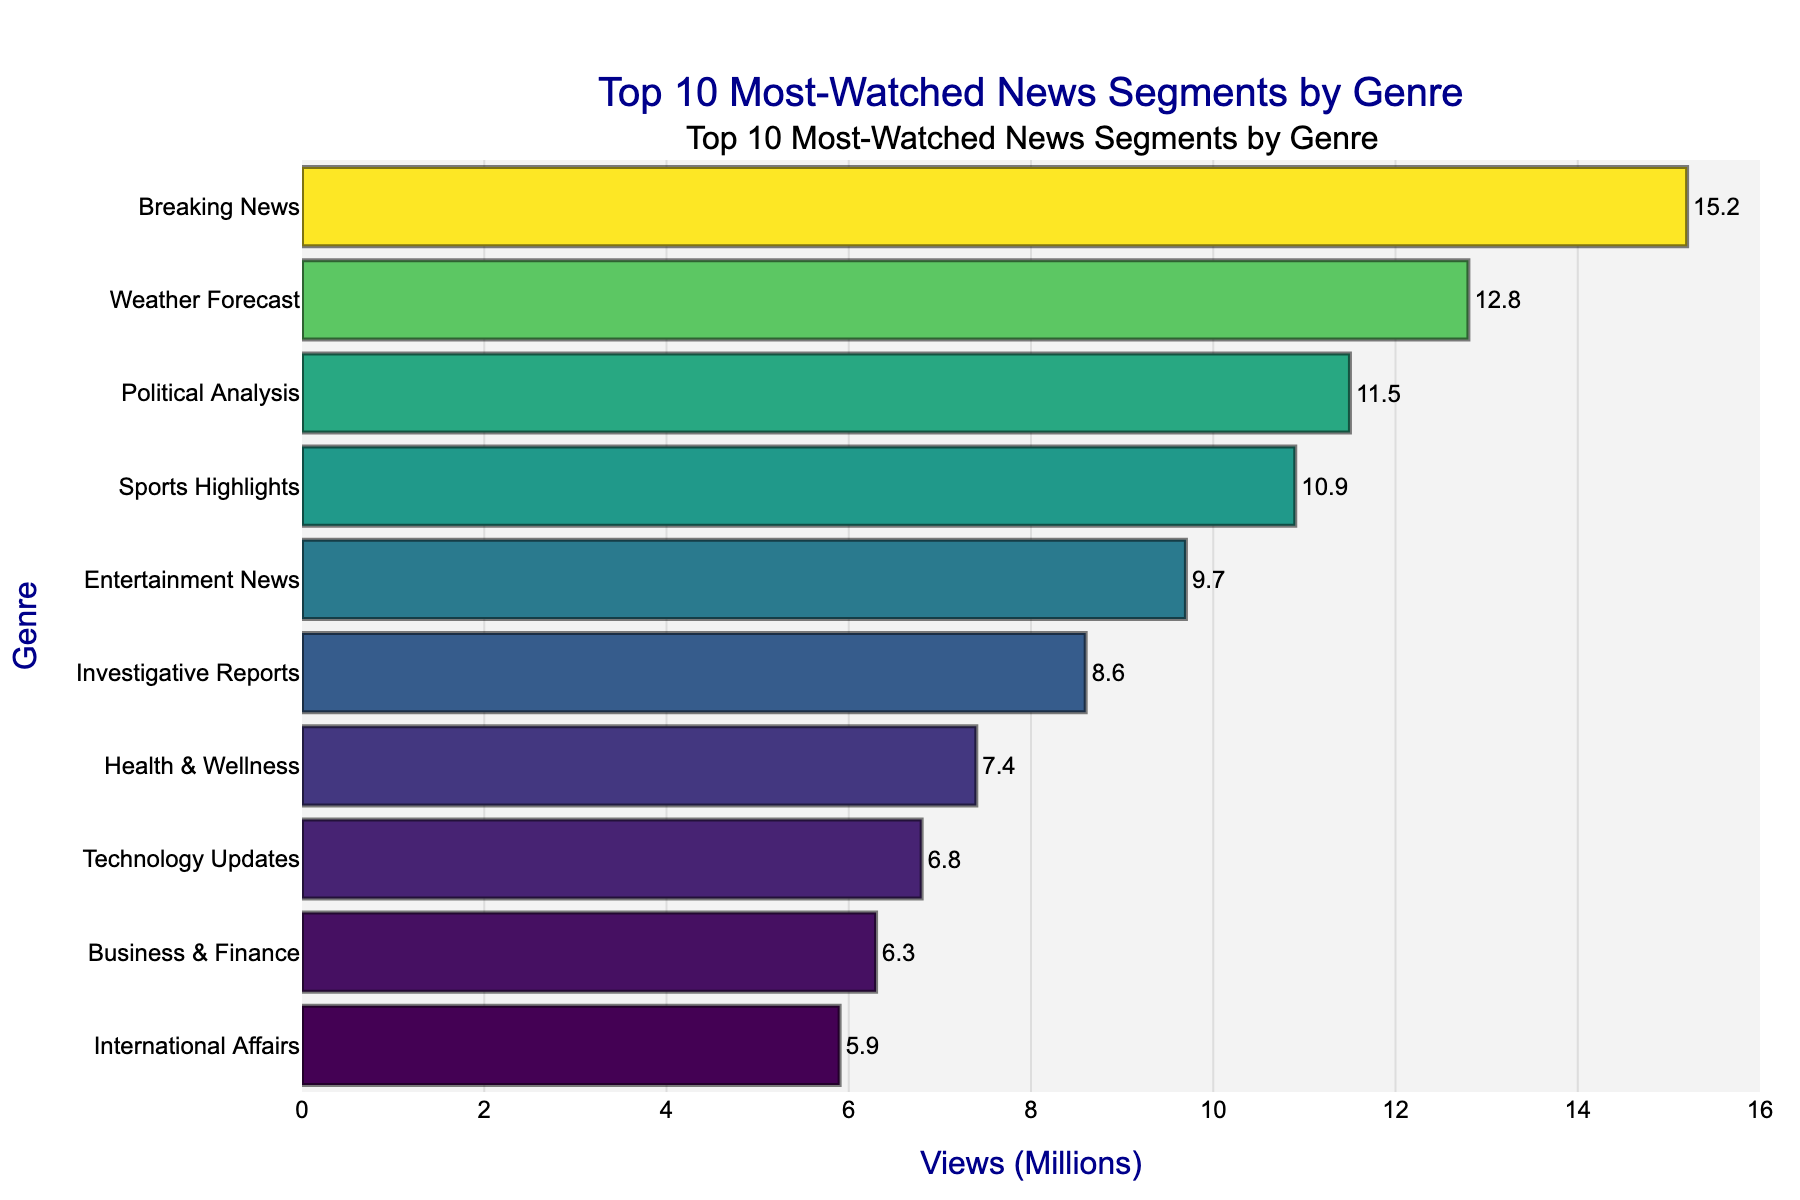Which genre has the most views? The bar chart shows Breaking News with the largest bar length, indicating it has the highest views.
Answer: Breaking News What's the total combined views of Breaking News and Entertainment News? Breaking News has 15.2 million views and Entertainment News has 9.7 million views. Summing these, 15.2 + 9.7 results in 24.9 million views.
Answer: 24.9 million Which genre has fewer views: Political Analysis or Weather Forecast? By comparing the lengths of the bars, Weather Forecast has more views with 12.8 million compared to Political Analysis with 11.5 million.
Answer: Political Analysis How much more popular is the Health & Wellness segment compared to Business & Finance? Health & Wellness has 7.4 million views, and Business & Finance has 6.3 million views. The difference is 7.4 - 6.3 which is 1.1 million views.
Answer: 1.1 million Which genre is the least popular and what is its view count? The bar chart shows International Affairs, with the shortest bar, has the least views of 5.9 million.
Answer: International Affairs, 5.9 million If you combine the views of the top three genres, what would be the total? The views for the top three genres are Breaking News (15.2), Weather Forecast (12.8), and Political Analysis (11.5). Summing them: 15.2 + 12.8 + 11.5 = 39.5 million.
Answer: 39.5 million What is the average number of views per genre? Sum all views: 15.2 + 12.8 + 11.5 + 10.9 + 9.7 + 8.6 + 7.4 + 6.8 + 6.3 + 5.9 = 95.1 million. There are 10 genres, so the average is 95.1 / 10 = 9.51 million.
Answer: 9.51 million Which genre has slightly more views: Technology Updates or Business & Finance? Technology Updates has 6.8 million views and Business & Finance has 6.3 million views, so Technology Updates is slightly more popular.
Answer: Technology Updates Is the difference in views between Sports Highlights and Investigative Reports greater than the difference between Health & Wellness and Technology Updates? Difference between Sports Highlights (10.9) and Investigative Reports (8.6) is 2.3 million. Difference between Health & Wellness (7.4) and Technology Updates (6.8) is 0.6 million. 2.3 million is greater than 0.6 million.
Answer: Yes 